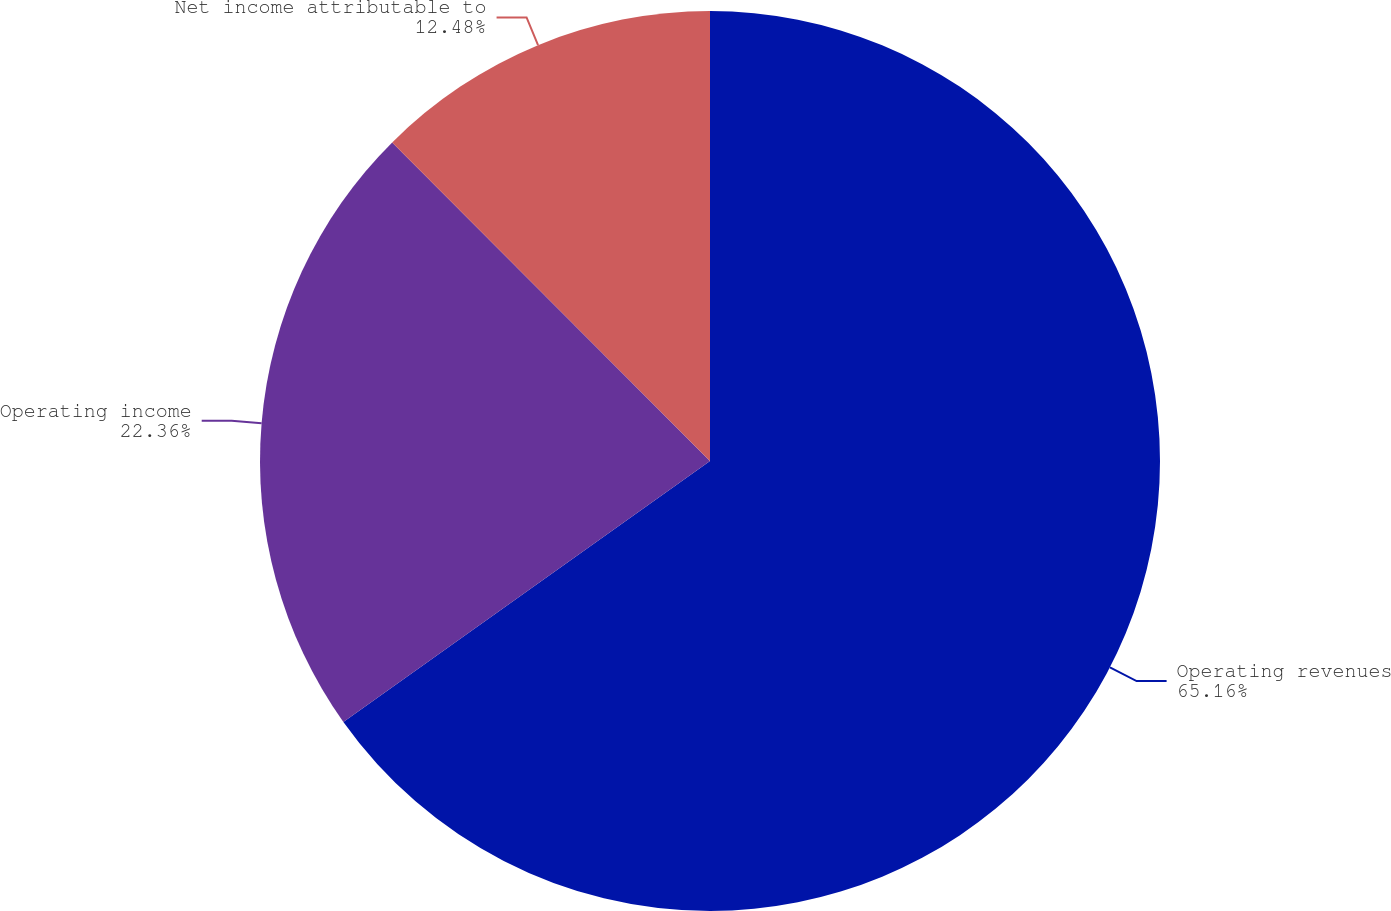Convert chart to OTSL. <chart><loc_0><loc_0><loc_500><loc_500><pie_chart><fcel>Operating revenues<fcel>Operating income<fcel>Net income attributable to<nl><fcel>65.15%<fcel>22.36%<fcel>12.48%<nl></chart> 